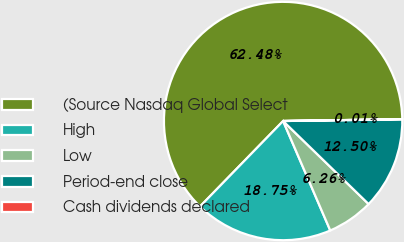<chart> <loc_0><loc_0><loc_500><loc_500><pie_chart><fcel>(Source Nasdaq Global Select<fcel>High<fcel>Low<fcel>Period-end close<fcel>Cash dividends declared<nl><fcel>62.47%<fcel>18.75%<fcel>6.26%<fcel>12.5%<fcel>0.01%<nl></chart> 